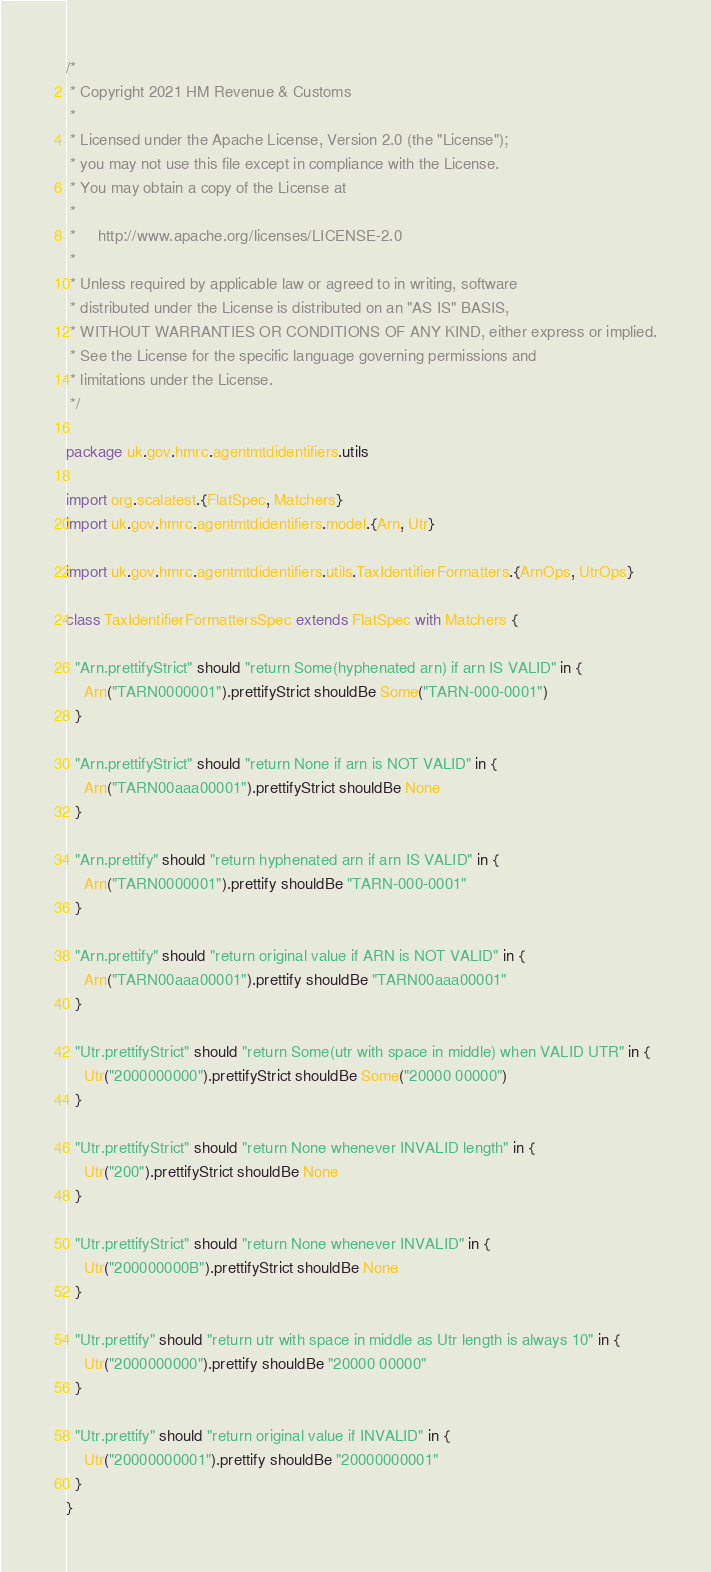Convert code to text. <code><loc_0><loc_0><loc_500><loc_500><_Scala_>/*
 * Copyright 2021 HM Revenue & Customs
 *
 * Licensed under the Apache License, Version 2.0 (the "License");
 * you may not use this file except in compliance with the License.
 * You may obtain a copy of the License at
 *
 *     http://www.apache.org/licenses/LICENSE-2.0
 *
 * Unless required by applicable law or agreed to in writing, software
 * distributed under the License is distributed on an "AS IS" BASIS,
 * WITHOUT WARRANTIES OR CONDITIONS OF ANY KIND, either express or implied.
 * See the License for the specific language governing permissions and
 * limitations under the License.
 */

package uk.gov.hmrc.agentmtdidentifiers.utils

import org.scalatest.{FlatSpec, Matchers}
import uk.gov.hmrc.agentmtdidentifiers.model.{Arn, Utr}

import uk.gov.hmrc.agentmtdidentifiers.utils.TaxIdentifierFormatters.{ArnOps, UtrOps}

class TaxIdentifierFormattersSpec extends FlatSpec with Matchers {

  "Arn.prettifyStrict" should "return Some(hyphenated arn) if arn IS VALID" in {
    Arn("TARN0000001").prettifyStrict shouldBe Some("TARN-000-0001")
  }

  "Arn.prettifyStrict" should "return None if arn is NOT VALID" in {
    Arn("TARN00aaa00001").prettifyStrict shouldBe None
  }

  "Arn.prettify" should "return hyphenated arn if arn IS VALID" in {
    Arn("TARN0000001").prettify shouldBe "TARN-000-0001"
  }

  "Arn.prettify" should "return original value if ARN is NOT VALID" in {
    Arn("TARN00aaa00001").prettify shouldBe "TARN00aaa00001"
  }

  "Utr.prettifyStrict" should "return Some(utr with space in middle) when VALID UTR" in {
    Utr("2000000000").prettifyStrict shouldBe Some("20000 00000")
  }

  "Utr.prettifyStrict" should "return None whenever INVALID length" in {
    Utr("200").prettifyStrict shouldBe None
  }

  "Utr.prettifyStrict" should "return None whenever INVALID" in {
    Utr("200000000B").prettifyStrict shouldBe None
  }

  "Utr.prettify" should "return utr with space in middle as Utr length is always 10" in {
    Utr("2000000000").prettify shouldBe "20000 00000"
  }

  "Utr.prettify" should "return original value if INVALID" in {
    Utr("20000000001").prettify shouldBe "20000000001"
  }
}
</code> 